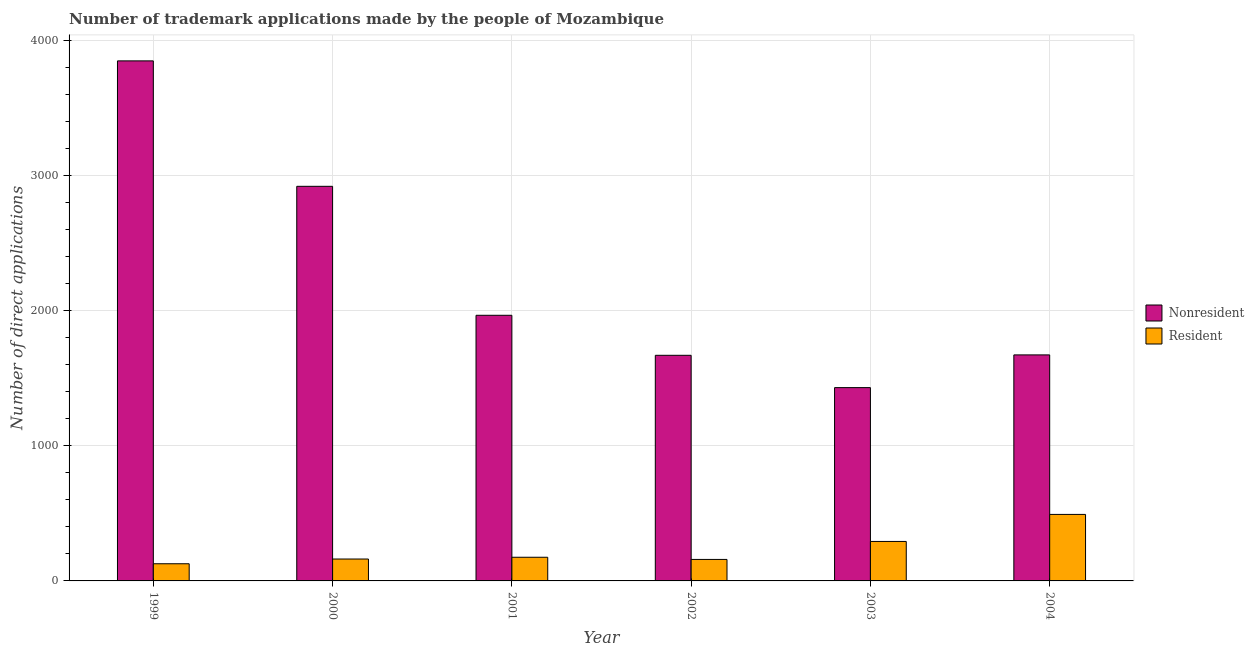How many different coloured bars are there?
Provide a succinct answer. 2. Are the number of bars on each tick of the X-axis equal?
Provide a succinct answer. Yes. How many bars are there on the 6th tick from the right?
Provide a short and direct response. 2. What is the number of trademark applications made by residents in 1999?
Make the answer very short. 127. Across all years, what is the maximum number of trademark applications made by non residents?
Offer a terse response. 3847. Across all years, what is the minimum number of trademark applications made by non residents?
Your answer should be compact. 1430. What is the total number of trademark applications made by non residents in the graph?
Provide a succinct answer. 1.35e+04. What is the difference between the number of trademark applications made by non residents in 2001 and that in 2002?
Your response must be concise. 296. What is the difference between the number of trademark applications made by residents in 2003 and the number of trademark applications made by non residents in 2002?
Your response must be concise. 133. What is the average number of trademark applications made by residents per year?
Your answer should be compact. 234.5. In how many years, is the number of trademark applications made by residents greater than 1400?
Keep it short and to the point. 0. What is the ratio of the number of trademark applications made by residents in 2001 to that in 2003?
Make the answer very short. 0.6. Is the number of trademark applications made by non residents in 1999 less than that in 2004?
Your answer should be very brief. No. Is the difference between the number of trademark applications made by residents in 1999 and 2004 greater than the difference between the number of trademark applications made by non residents in 1999 and 2004?
Give a very brief answer. No. What is the difference between the highest and the second highest number of trademark applications made by non residents?
Provide a short and direct response. 928. What is the difference between the highest and the lowest number of trademark applications made by non residents?
Your response must be concise. 2417. In how many years, is the number of trademark applications made by residents greater than the average number of trademark applications made by residents taken over all years?
Offer a terse response. 2. What does the 2nd bar from the left in 2000 represents?
Give a very brief answer. Resident. What does the 1st bar from the right in 2003 represents?
Your response must be concise. Resident. How many bars are there?
Provide a short and direct response. 12. How many years are there in the graph?
Ensure brevity in your answer.  6. Does the graph contain any zero values?
Offer a terse response. No. Does the graph contain grids?
Keep it short and to the point. Yes. What is the title of the graph?
Your answer should be very brief. Number of trademark applications made by the people of Mozambique. What is the label or title of the X-axis?
Your response must be concise. Year. What is the label or title of the Y-axis?
Keep it short and to the point. Number of direct applications. What is the Number of direct applications in Nonresident in 1999?
Provide a succinct answer. 3847. What is the Number of direct applications in Resident in 1999?
Provide a succinct answer. 127. What is the Number of direct applications of Nonresident in 2000?
Offer a terse response. 2919. What is the Number of direct applications in Resident in 2000?
Make the answer very short. 162. What is the Number of direct applications in Nonresident in 2001?
Offer a very short reply. 1965. What is the Number of direct applications of Resident in 2001?
Your answer should be compact. 175. What is the Number of direct applications of Nonresident in 2002?
Your answer should be compact. 1669. What is the Number of direct applications in Resident in 2002?
Your answer should be compact. 159. What is the Number of direct applications of Nonresident in 2003?
Keep it short and to the point. 1430. What is the Number of direct applications of Resident in 2003?
Make the answer very short. 292. What is the Number of direct applications of Nonresident in 2004?
Provide a succinct answer. 1672. What is the Number of direct applications of Resident in 2004?
Give a very brief answer. 492. Across all years, what is the maximum Number of direct applications in Nonresident?
Your response must be concise. 3847. Across all years, what is the maximum Number of direct applications of Resident?
Provide a short and direct response. 492. Across all years, what is the minimum Number of direct applications in Nonresident?
Your response must be concise. 1430. Across all years, what is the minimum Number of direct applications in Resident?
Your answer should be compact. 127. What is the total Number of direct applications of Nonresident in the graph?
Provide a succinct answer. 1.35e+04. What is the total Number of direct applications of Resident in the graph?
Your answer should be compact. 1407. What is the difference between the Number of direct applications of Nonresident in 1999 and that in 2000?
Offer a terse response. 928. What is the difference between the Number of direct applications in Resident in 1999 and that in 2000?
Ensure brevity in your answer.  -35. What is the difference between the Number of direct applications of Nonresident in 1999 and that in 2001?
Offer a very short reply. 1882. What is the difference between the Number of direct applications of Resident in 1999 and that in 2001?
Your answer should be very brief. -48. What is the difference between the Number of direct applications in Nonresident in 1999 and that in 2002?
Your response must be concise. 2178. What is the difference between the Number of direct applications in Resident in 1999 and that in 2002?
Offer a terse response. -32. What is the difference between the Number of direct applications in Nonresident in 1999 and that in 2003?
Provide a succinct answer. 2417. What is the difference between the Number of direct applications of Resident in 1999 and that in 2003?
Provide a succinct answer. -165. What is the difference between the Number of direct applications in Nonresident in 1999 and that in 2004?
Your answer should be very brief. 2175. What is the difference between the Number of direct applications of Resident in 1999 and that in 2004?
Your answer should be compact. -365. What is the difference between the Number of direct applications of Nonresident in 2000 and that in 2001?
Your answer should be very brief. 954. What is the difference between the Number of direct applications in Nonresident in 2000 and that in 2002?
Your answer should be compact. 1250. What is the difference between the Number of direct applications in Nonresident in 2000 and that in 2003?
Give a very brief answer. 1489. What is the difference between the Number of direct applications in Resident in 2000 and that in 2003?
Make the answer very short. -130. What is the difference between the Number of direct applications in Nonresident in 2000 and that in 2004?
Give a very brief answer. 1247. What is the difference between the Number of direct applications of Resident in 2000 and that in 2004?
Provide a succinct answer. -330. What is the difference between the Number of direct applications of Nonresident in 2001 and that in 2002?
Offer a very short reply. 296. What is the difference between the Number of direct applications of Nonresident in 2001 and that in 2003?
Your response must be concise. 535. What is the difference between the Number of direct applications in Resident in 2001 and that in 2003?
Make the answer very short. -117. What is the difference between the Number of direct applications of Nonresident in 2001 and that in 2004?
Provide a succinct answer. 293. What is the difference between the Number of direct applications in Resident in 2001 and that in 2004?
Ensure brevity in your answer.  -317. What is the difference between the Number of direct applications in Nonresident in 2002 and that in 2003?
Your answer should be compact. 239. What is the difference between the Number of direct applications of Resident in 2002 and that in 2003?
Your response must be concise. -133. What is the difference between the Number of direct applications in Nonresident in 2002 and that in 2004?
Your answer should be very brief. -3. What is the difference between the Number of direct applications of Resident in 2002 and that in 2004?
Offer a very short reply. -333. What is the difference between the Number of direct applications in Nonresident in 2003 and that in 2004?
Provide a succinct answer. -242. What is the difference between the Number of direct applications in Resident in 2003 and that in 2004?
Offer a terse response. -200. What is the difference between the Number of direct applications in Nonresident in 1999 and the Number of direct applications in Resident in 2000?
Offer a very short reply. 3685. What is the difference between the Number of direct applications of Nonresident in 1999 and the Number of direct applications of Resident in 2001?
Provide a succinct answer. 3672. What is the difference between the Number of direct applications of Nonresident in 1999 and the Number of direct applications of Resident in 2002?
Keep it short and to the point. 3688. What is the difference between the Number of direct applications of Nonresident in 1999 and the Number of direct applications of Resident in 2003?
Keep it short and to the point. 3555. What is the difference between the Number of direct applications in Nonresident in 1999 and the Number of direct applications in Resident in 2004?
Keep it short and to the point. 3355. What is the difference between the Number of direct applications in Nonresident in 2000 and the Number of direct applications in Resident in 2001?
Ensure brevity in your answer.  2744. What is the difference between the Number of direct applications of Nonresident in 2000 and the Number of direct applications of Resident in 2002?
Your response must be concise. 2760. What is the difference between the Number of direct applications of Nonresident in 2000 and the Number of direct applications of Resident in 2003?
Provide a succinct answer. 2627. What is the difference between the Number of direct applications in Nonresident in 2000 and the Number of direct applications in Resident in 2004?
Give a very brief answer. 2427. What is the difference between the Number of direct applications in Nonresident in 2001 and the Number of direct applications in Resident in 2002?
Give a very brief answer. 1806. What is the difference between the Number of direct applications in Nonresident in 2001 and the Number of direct applications in Resident in 2003?
Ensure brevity in your answer.  1673. What is the difference between the Number of direct applications in Nonresident in 2001 and the Number of direct applications in Resident in 2004?
Ensure brevity in your answer.  1473. What is the difference between the Number of direct applications in Nonresident in 2002 and the Number of direct applications in Resident in 2003?
Provide a short and direct response. 1377. What is the difference between the Number of direct applications of Nonresident in 2002 and the Number of direct applications of Resident in 2004?
Ensure brevity in your answer.  1177. What is the difference between the Number of direct applications of Nonresident in 2003 and the Number of direct applications of Resident in 2004?
Offer a terse response. 938. What is the average Number of direct applications of Nonresident per year?
Provide a short and direct response. 2250.33. What is the average Number of direct applications in Resident per year?
Provide a succinct answer. 234.5. In the year 1999, what is the difference between the Number of direct applications in Nonresident and Number of direct applications in Resident?
Give a very brief answer. 3720. In the year 2000, what is the difference between the Number of direct applications of Nonresident and Number of direct applications of Resident?
Your answer should be compact. 2757. In the year 2001, what is the difference between the Number of direct applications of Nonresident and Number of direct applications of Resident?
Provide a succinct answer. 1790. In the year 2002, what is the difference between the Number of direct applications in Nonresident and Number of direct applications in Resident?
Give a very brief answer. 1510. In the year 2003, what is the difference between the Number of direct applications of Nonresident and Number of direct applications of Resident?
Your answer should be very brief. 1138. In the year 2004, what is the difference between the Number of direct applications of Nonresident and Number of direct applications of Resident?
Your response must be concise. 1180. What is the ratio of the Number of direct applications of Nonresident in 1999 to that in 2000?
Ensure brevity in your answer.  1.32. What is the ratio of the Number of direct applications in Resident in 1999 to that in 2000?
Your answer should be very brief. 0.78. What is the ratio of the Number of direct applications in Nonresident in 1999 to that in 2001?
Offer a terse response. 1.96. What is the ratio of the Number of direct applications of Resident in 1999 to that in 2001?
Ensure brevity in your answer.  0.73. What is the ratio of the Number of direct applications of Nonresident in 1999 to that in 2002?
Provide a short and direct response. 2.31. What is the ratio of the Number of direct applications in Resident in 1999 to that in 2002?
Your answer should be very brief. 0.8. What is the ratio of the Number of direct applications in Nonresident in 1999 to that in 2003?
Give a very brief answer. 2.69. What is the ratio of the Number of direct applications of Resident in 1999 to that in 2003?
Your answer should be compact. 0.43. What is the ratio of the Number of direct applications in Nonresident in 1999 to that in 2004?
Provide a short and direct response. 2.3. What is the ratio of the Number of direct applications of Resident in 1999 to that in 2004?
Provide a short and direct response. 0.26. What is the ratio of the Number of direct applications in Nonresident in 2000 to that in 2001?
Offer a terse response. 1.49. What is the ratio of the Number of direct applications of Resident in 2000 to that in 2001?
Provide a short and direct response. 0.93. What is the ratio of the Number of direct applications of Nonresident in 2000 to that in 2002?
Give a very brief answer. 1.75. What is the ratio of the Number of direct applications in Resident in 2000 to that in 2002?
Make the answer very short. 1.02. What is the ratio of the Number of direct applications of Nonresident in 2000 to that in 2003?
Give a very brief answer. 2.04. What is the ratio of the Number of direct applications in Resident in 2000 to that in 2003?
Provide a short and direct response. 0.55. What is the ratio of the Number of direct applications in Nonresident in 2000 to that in 2004?
Offer a terse response. 1.75. What is the ratio of the Number of direct applications in Resident in 2000 to that in 2004?
Offer a terse response. 0.33. What is the ratio of the Number of direct applications in Nonresident in 2001 to that in 2002?
Offer a very short reply. 1.18. What is the ratio of the Number of direct applications in Resident in 2001 to that in 2002?
Give a very brief answer. 1.1. What is the ratio of the Number of direct applications in Nonresident in 2001 to that in 2003?
Provide a short and direct response. 1.37. What is the ratio of the Number of direct applications in Resident in 2001 to that in 2003?
Offer a terse response. 0.6. What is the ratio of the Number of direct applications in Nonresident in 2001 to that in 2004?
Offer a terse response. 1.18. What is the ratio of the Number of direct applications in Resident in 2001 to that in 2004?
Provide a short and direct response. 0.36. What is the ratio of the Number of direct applications of Nonresident in 2002 to that in 2003?
Ensure brevity in your answer.  1.17. What is the ratio of the Number of direct applications in Resident in 2002 to that in 2003?
Keep it short and to the point. 0.54. What is the ratio of the Number of direct applications of Nonresident in 2002 to that in 2004?
Your response must be concise. 1. What is the ratio of the Number of direct applications of Resident in 2002 to that in 2004?
Make the answer very short. 0.32. What is the ratio of the Number of direct applications of Nonresident in 2003 to that in 2004?
Keep it short and to the point. 0.86. What is the ratio of the Number of direct applications in Resident in 2003 to that in 2004?
Your response must be concise. 0.59. What is the difference between the highest and the second highest Number of direct applications in Nonresident?
Keep it short and to the point. 928. What is the difference between the highest and the lowest Number of direct applications in Nonresident?
Provide a short and direct response. 2417. What is the difference between the highest and the lowest Number of direct applications of Resident?
Give a very brief answer. 365. 